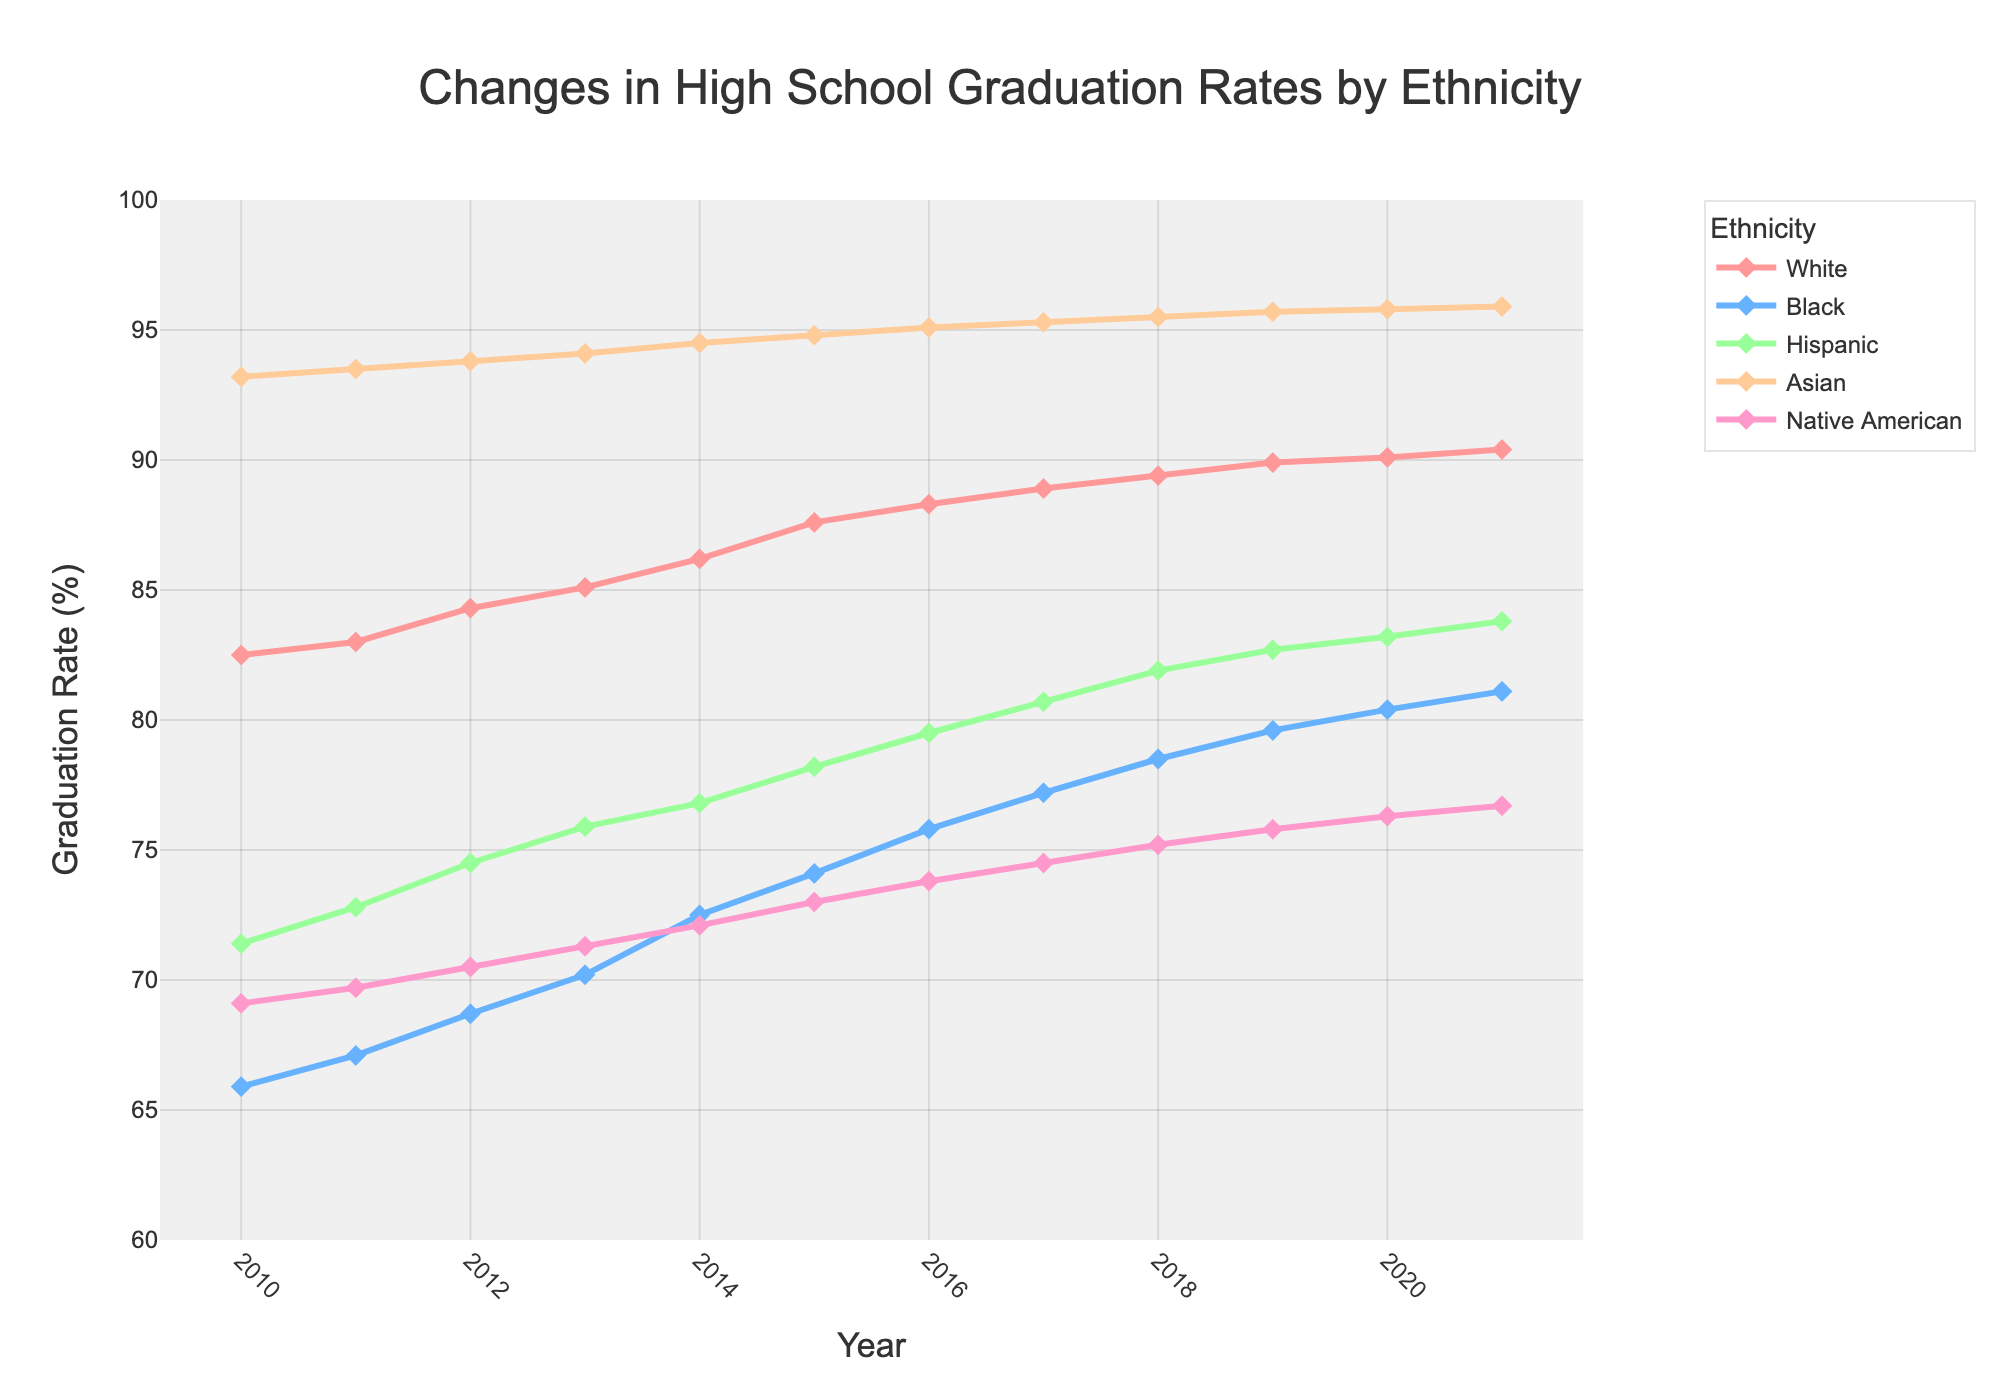What is the trend of high school graduation rates for White students from 2010 to 2021? The graduation rate for White students increased from 82.5% in 2010 to 90.4% in 2021. By examining the line plot, the trajectory consistently goes upward.
Answer: Upward trend Which ethnicity had the highest graduation rate in 2014, and what was it? In 2014, the ethnicity with the highest graduation rate was Asian students, with a rate of 94.5%. This can be determined by identifying the highest point on the 2014 vertical line on the chart and noting the associated ethnic group.
Answer: Asian, 94.5% By how much did the graduation rate for Black students increase from 2010 to 2018? The graduation rate for Black students increased from 65.9% in 2010 to 78.5% in 2018. The difference is calculated as 78.5 - 65.9.
Answer: 12.6% Which ethnicity had the lowest graduation rate in 2010, and how does it compare to the rate in 2021? In 2010, Black students had the lowest graduation rate at 65.9%. By 2021, this rate increased to 81.1%. Comparing the two values, the increase is 81.1 - 65.9.
Answer: Black, 65.9% to 81.1% What is the average graduation rate for Hispanic students over the entire period? To find the average graduation rate for Hispanic students from 2010 to 2021, sum the graduation rates for each year and divide by the number of years. The sum is 71.4 + 72.8 + 74.5 + 75.9 + 76.8 + 78.2 + 79.5 + 80.7 + 81.9 + 82.7 + 83.2 + 83.8. There are 12 years.
Answer: 77.616% Compare the graduation rates of Native American and Hispanic students in 2015. Which group had a higher rate and by how much? In 2015, the graduation rate for Native American students was 73.0%, and for Hispanic students, it was 78.2%. The difference is 78.2 - 73.0.
Answer: Hispanic by 5.2% How did the graduation rate for Asian students change between 2016 and 2020? The graduation rate for Asian students increased slightly from 95.1% in 2016 to 95.8% in 2020. The difference is calculated as 95.8 - 95.1.
Answer: Increased by 0.7% Between which two consecutive years did White students see the highest increase in graduation rates? By examining year-over-year changes for White students, the highest increase occurred between 2014 and 2015, where the rate increased from 86.2% to 87.6%. The increase is 87.6 - 86.2.
Answer: 2014 to 2015 Which two ethnicities had the closest graduation rates in 2020, and what were the rates? In 2020, the graduation rates for Black and Hispanic students were very close at 80.4% and 83.2%, respectively.
Answer: Black and Hispanic, 80.4% and 83.2% 